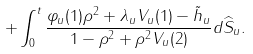<formula> <loc_0><loc_0><loc_500><loc_500>+ \int _ { 0 } ^ { t } \frac { \varphi _ { u } ( 1 ) \rho ^ { 2 } + \lambda _ { u } V _ { u } ( 1 ) - \tilde { h } _ { u } } { 1 - \rho ^ { 2 } + \rho ^ { 2 } V _ { u } ( 2 ) } d \widehat { S } _ { u } .</formula> 